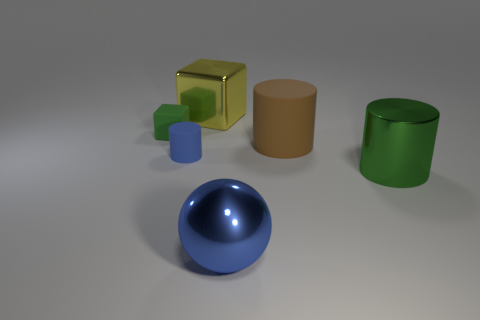There is a green thing behind the metallic thing that is on the right side of the matte thing to the right of the big blue thing; what is it made of?
Give a very brief answer. Rubber. Does the shiny sphere have the same color as the big block?
Provide a succinct answer. No. Is there a metal cube that has the same color as the large sphere?
Your answer should be compact. No. There is a rubber object that is the same size as the blue cylinder; what is its shape?
Provide a short and direct response. Cube. Is the number of big blue metal objects less than the number of tiny gray rubber objects?
Provide a short and direct response. No. What number of metal cubes have the same size as the brown cylinder?
Ensure brevity in your answer.  1. What shape is the large thing that is the same color as the tiny cylinder?
Offer a very short reply. Sphere. What material is the big brown thing?
Your answer should be very brief. Rubber. What is the size of the blue object behind the large blue metallic object?
Your answer should be compact. Small. How many other large brown objects have the same shape as the big matte object?
Ensure brevity in your answer.  0. 